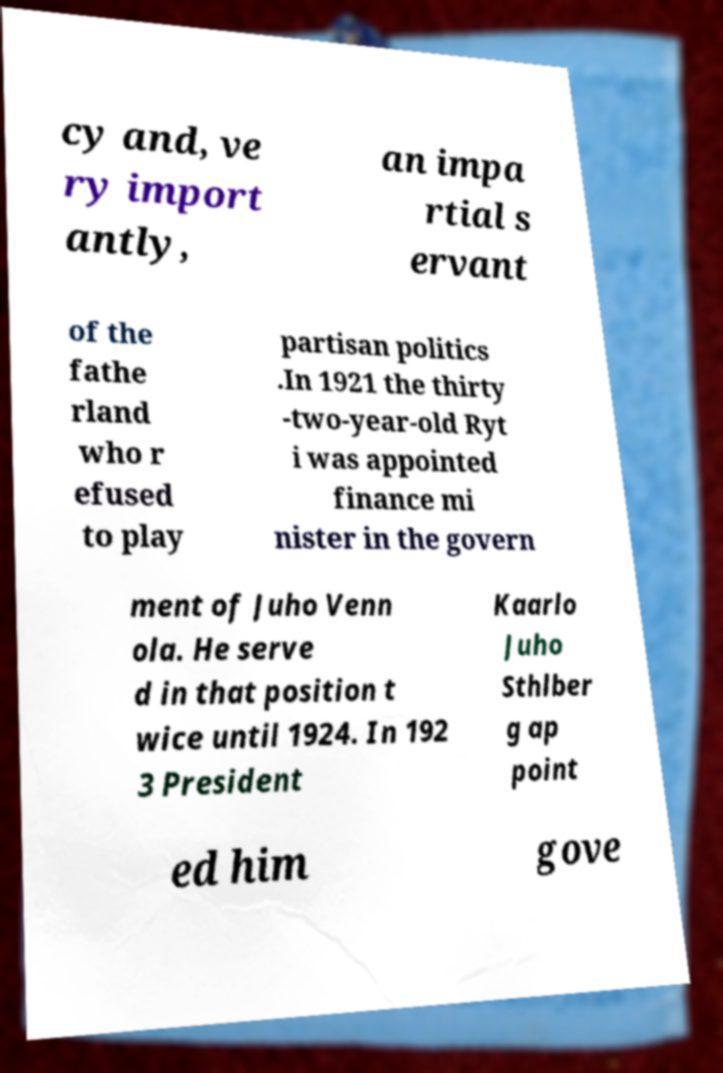There's text embedded in this image that I need extracted. Can you transcribe it verbatim? cy and, ve ry import antly, an impa rtial s ervant of the fathe rland who r efused to play partisan politics .In 1921 the thirty -two-year-old Ryt i was appointed finance mi nister in the govern ment of Juho Venn ola. He serve d in that position t wice until 1924. In 192 3 President Kaarlo Juho Sthlber g ap point ed him gove 